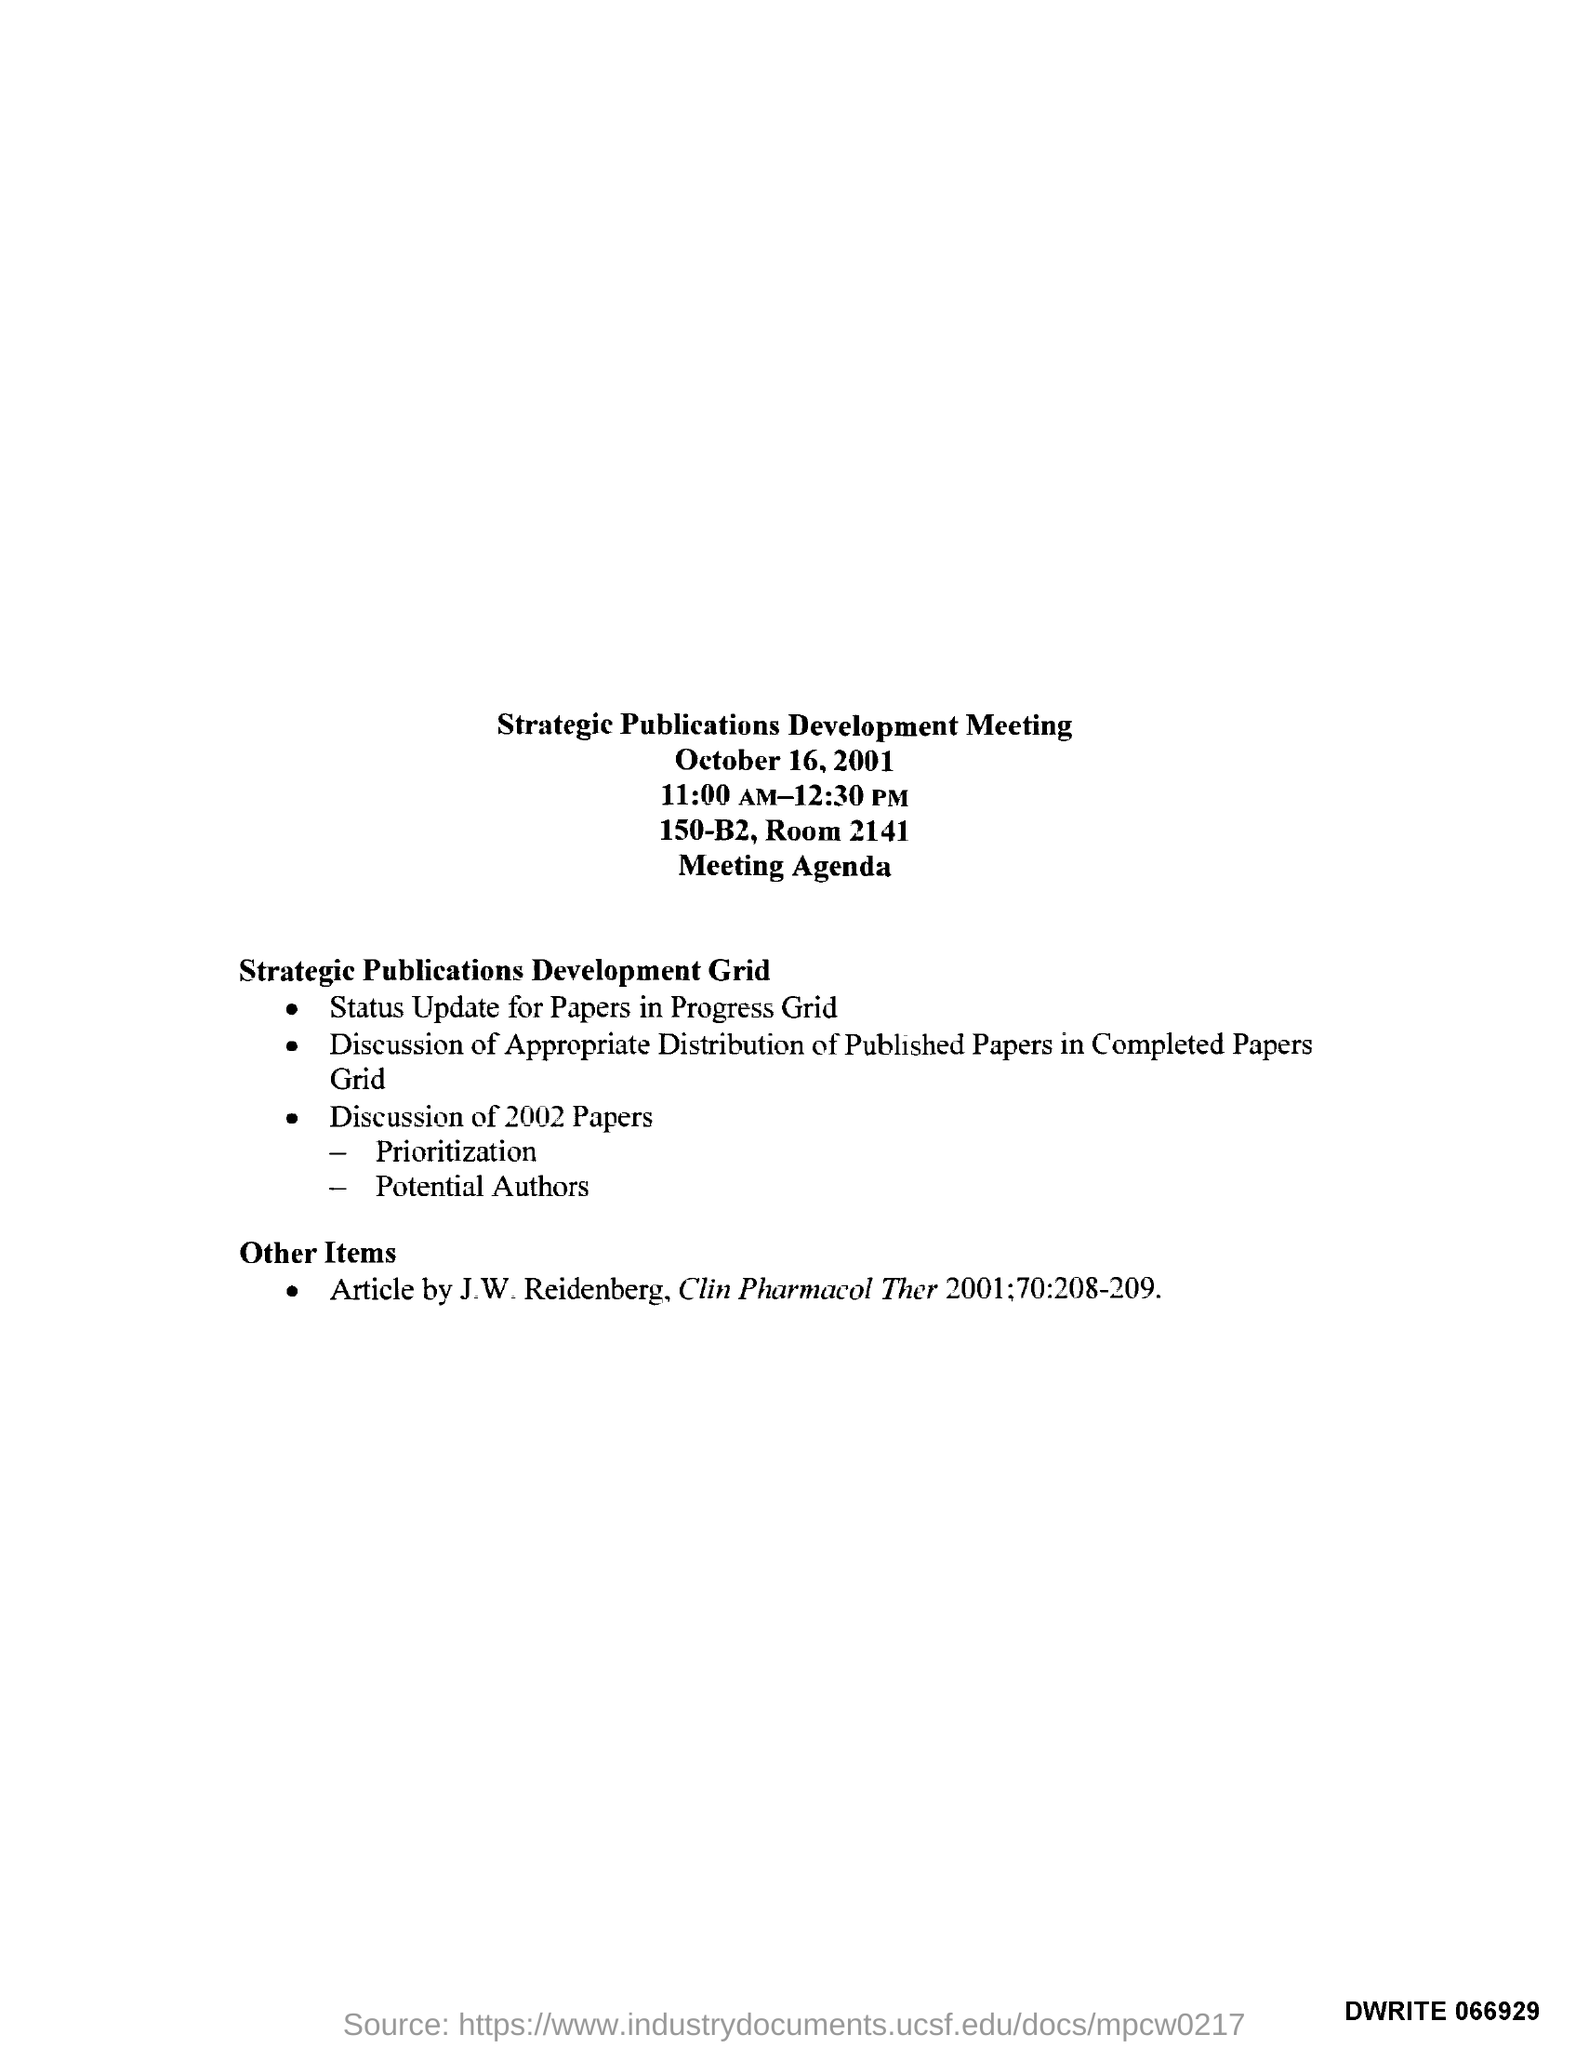Highlight a few significant elements in this photo. The title of the document is "Strategic Publications Development Meeting. The room number is 2141," the speaker declared. 